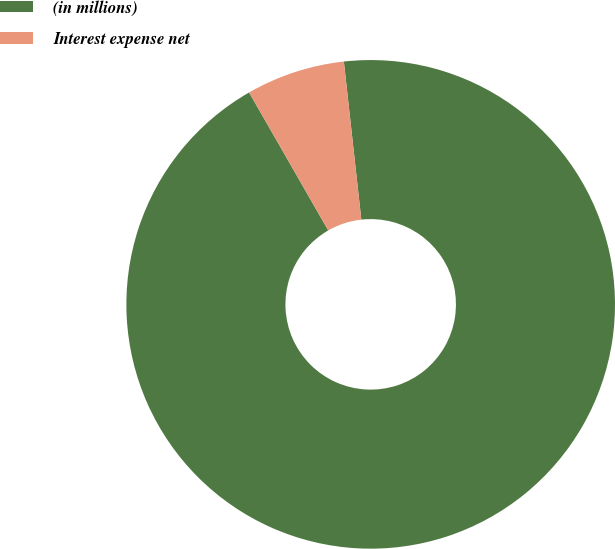Convert chart to OTSL. <chart><loc_0><loc_0><loc_500><loc_500><pie_chart><fcel>(in millions)<fcel>Interest expense net<nl><fcel>93.46%<fcel>6.54%<nl></chart> 